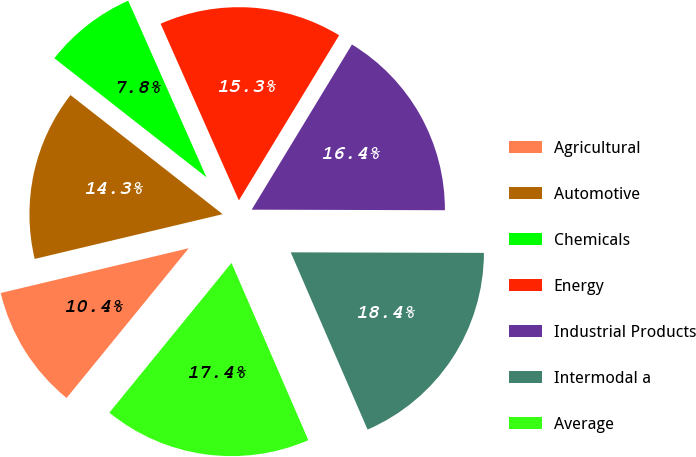Convert chart. <chart><loc_0><loc_0><loc_500><loc_500><pie_chart><fcel>Agricultural<fcel>Automotive<fcel>Chemicals<fcel>Energy<fcel>Industrial Products<fcel>Intermodal a<fcel>Average<nl><fcel>10.39%<fcel>14.29%<fcel>7.79%<fcel>15.32%<fcel>16.36%<fcel>18.44%<fcel>17.4%<nl></chart> 